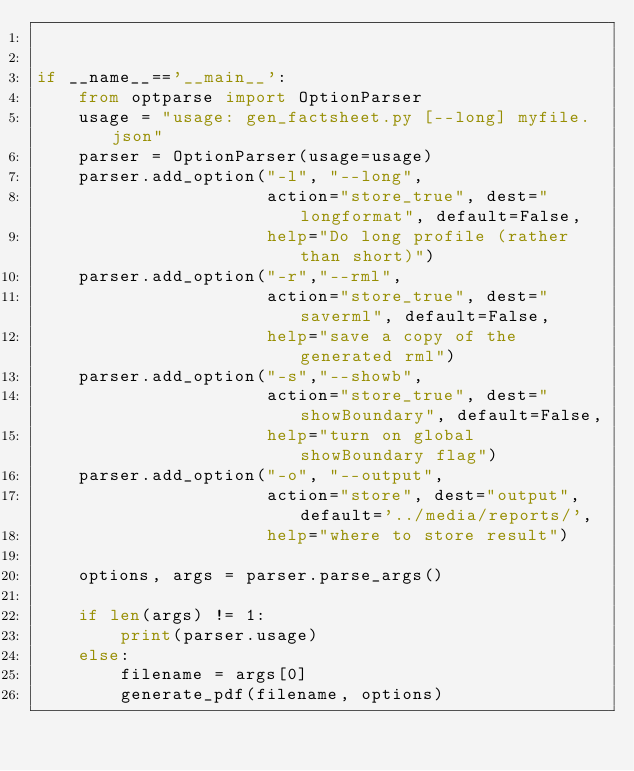<code> <loc_0><loc_0><loc_500><loc_500><_Python_>

if __name__=='__main__':
    from optparse import OptionParser
    usage = "usage: gen_factsheet.py [--long] myfile.json"
    parser = OptionParser(usage=usage)
    parser.add_option("-l", "--long",
                      action="store_true", dest="longformat", default=False,
                      help="Do long profile (rather than short)")
    parser.add_option("-r","--rml",
                      action="store_true", dest="saverml", default=False,
                      help="save a copy of the generated rml")
    parser.add_option("-s","--showb",
                      action="store_true", dest="showBoundary", default=False,
                      help="turn on global showBoundary flag")
    parser.add_option("-o", "--output",
                      action="store", dest="output", default='../media/reports/',
                      help="where to store result")

    options, args = parser.parse_args()

    if len(args) != 1:
        print(parser.usage)
    else:
        filename = args[0]
        generate_pdf(filename, options)

</code> 